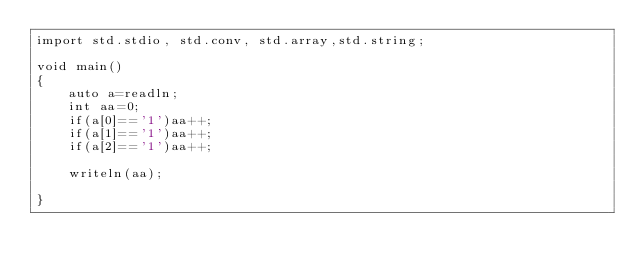Convert code to text. <code><loc_0><loc_0><loc_500><loc_500><_D_>import std.stdio, std.conv, std.array,std.string;

void main()
{
    auto a=readln;
    int aa=0;
    if(a[0]=='1')aa++;
    if(a[1]=='1')aa++;
    if(a[2]=='1')aa++;
    
    writeln(aa);
    
}</code> 